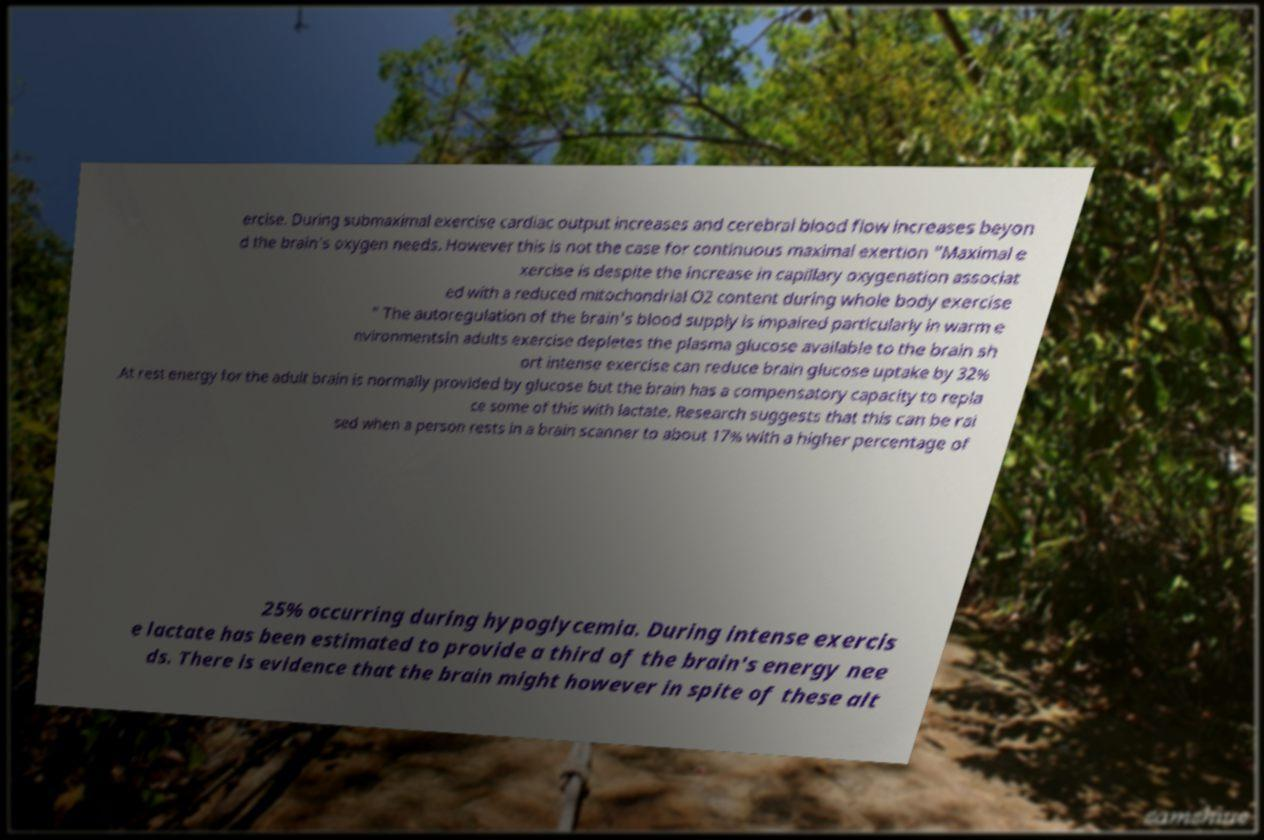Could you assist in decoding the text presented in this image and type it out clearly? ercise. During submaximal exercise cardiac output increases and cerebral blood flow increases beyon d the brain's oxygen needs. However this is not the case for continuous maximal exertion "Maximal e xercise is despite the increase in capillary oxygenation associat ed with a reduced mitochondrial O2 content during whole body exercise " The autoregulation of the brain's blood supply is impaired particularly in warm e nvironmentsIn adults exercise depletes the plasma glucose available to the brain sh ort intense exercise can reduce brain glucose uptake by 32% .At rest energy for the adult brain is normally provided by glucose but the brain has a compensatory capacity to repla ce some of this with lactate. Research suggests that this can be rai sed when a person rests in a brain scanner to about 17% with a higher percentage of 25% occurring during hypoglycemia. During intense exercis e lactate has been estimated to provide a third of the brain's energy nee ds. There is evidence that the brain might however in spite of these alt 